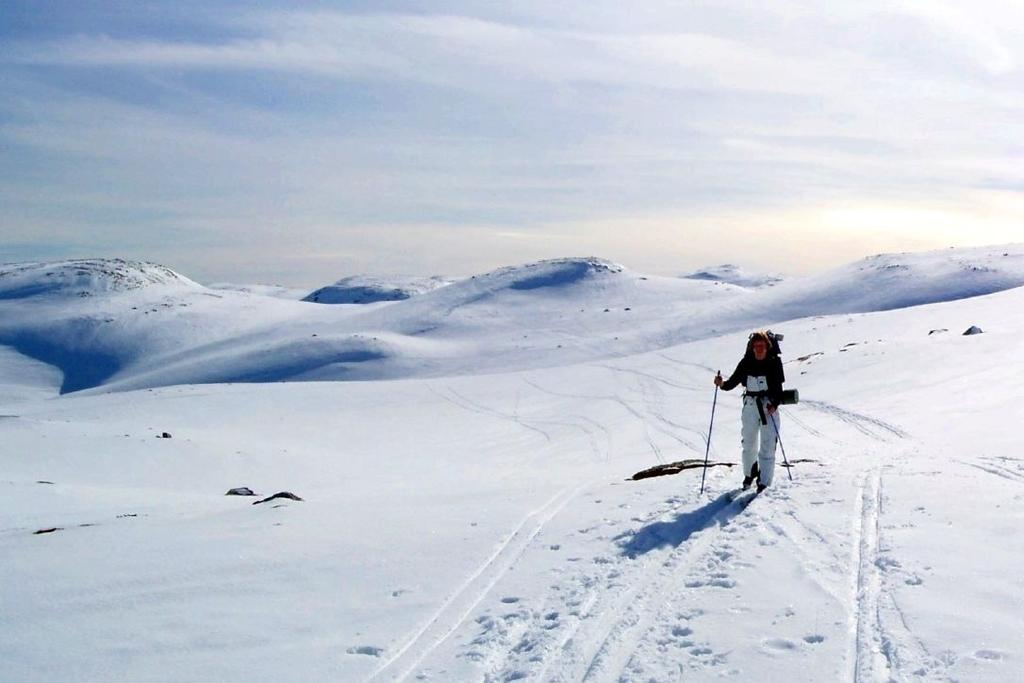Who is present in the image? There is a person in the image. What is the person wearing? The person is wearing a snow dress. What is the person doing in the image? The person is walking on snow. What can be seen in the background of the image? There are hills covered with snow in the background. What is visible in the sky in the image? The sky is visible with clouds. What type of ring can be seen on the person's finger in the image? There is no ring visible on the person's finger in the image. What kind of beef dish is being prepared in the background of the image? There is no beef dish or any food preparation visible in the image. 